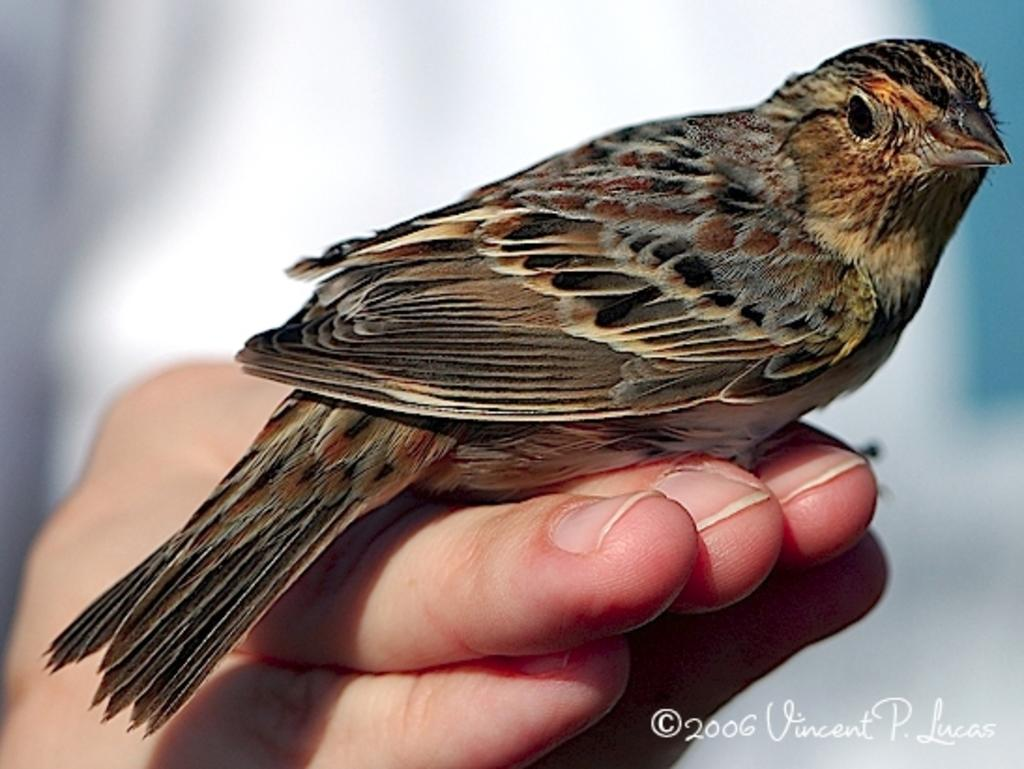What type of bird is in the image? There is a rose-breasted grosbeak in the image. Where is the bird located in the image? The bird is on a person's hand. What type of cheese is being cut with scissors on the floor in the image? There is no cheese or scissors present in the image, and the floor is not mentioned in the provided facts. 